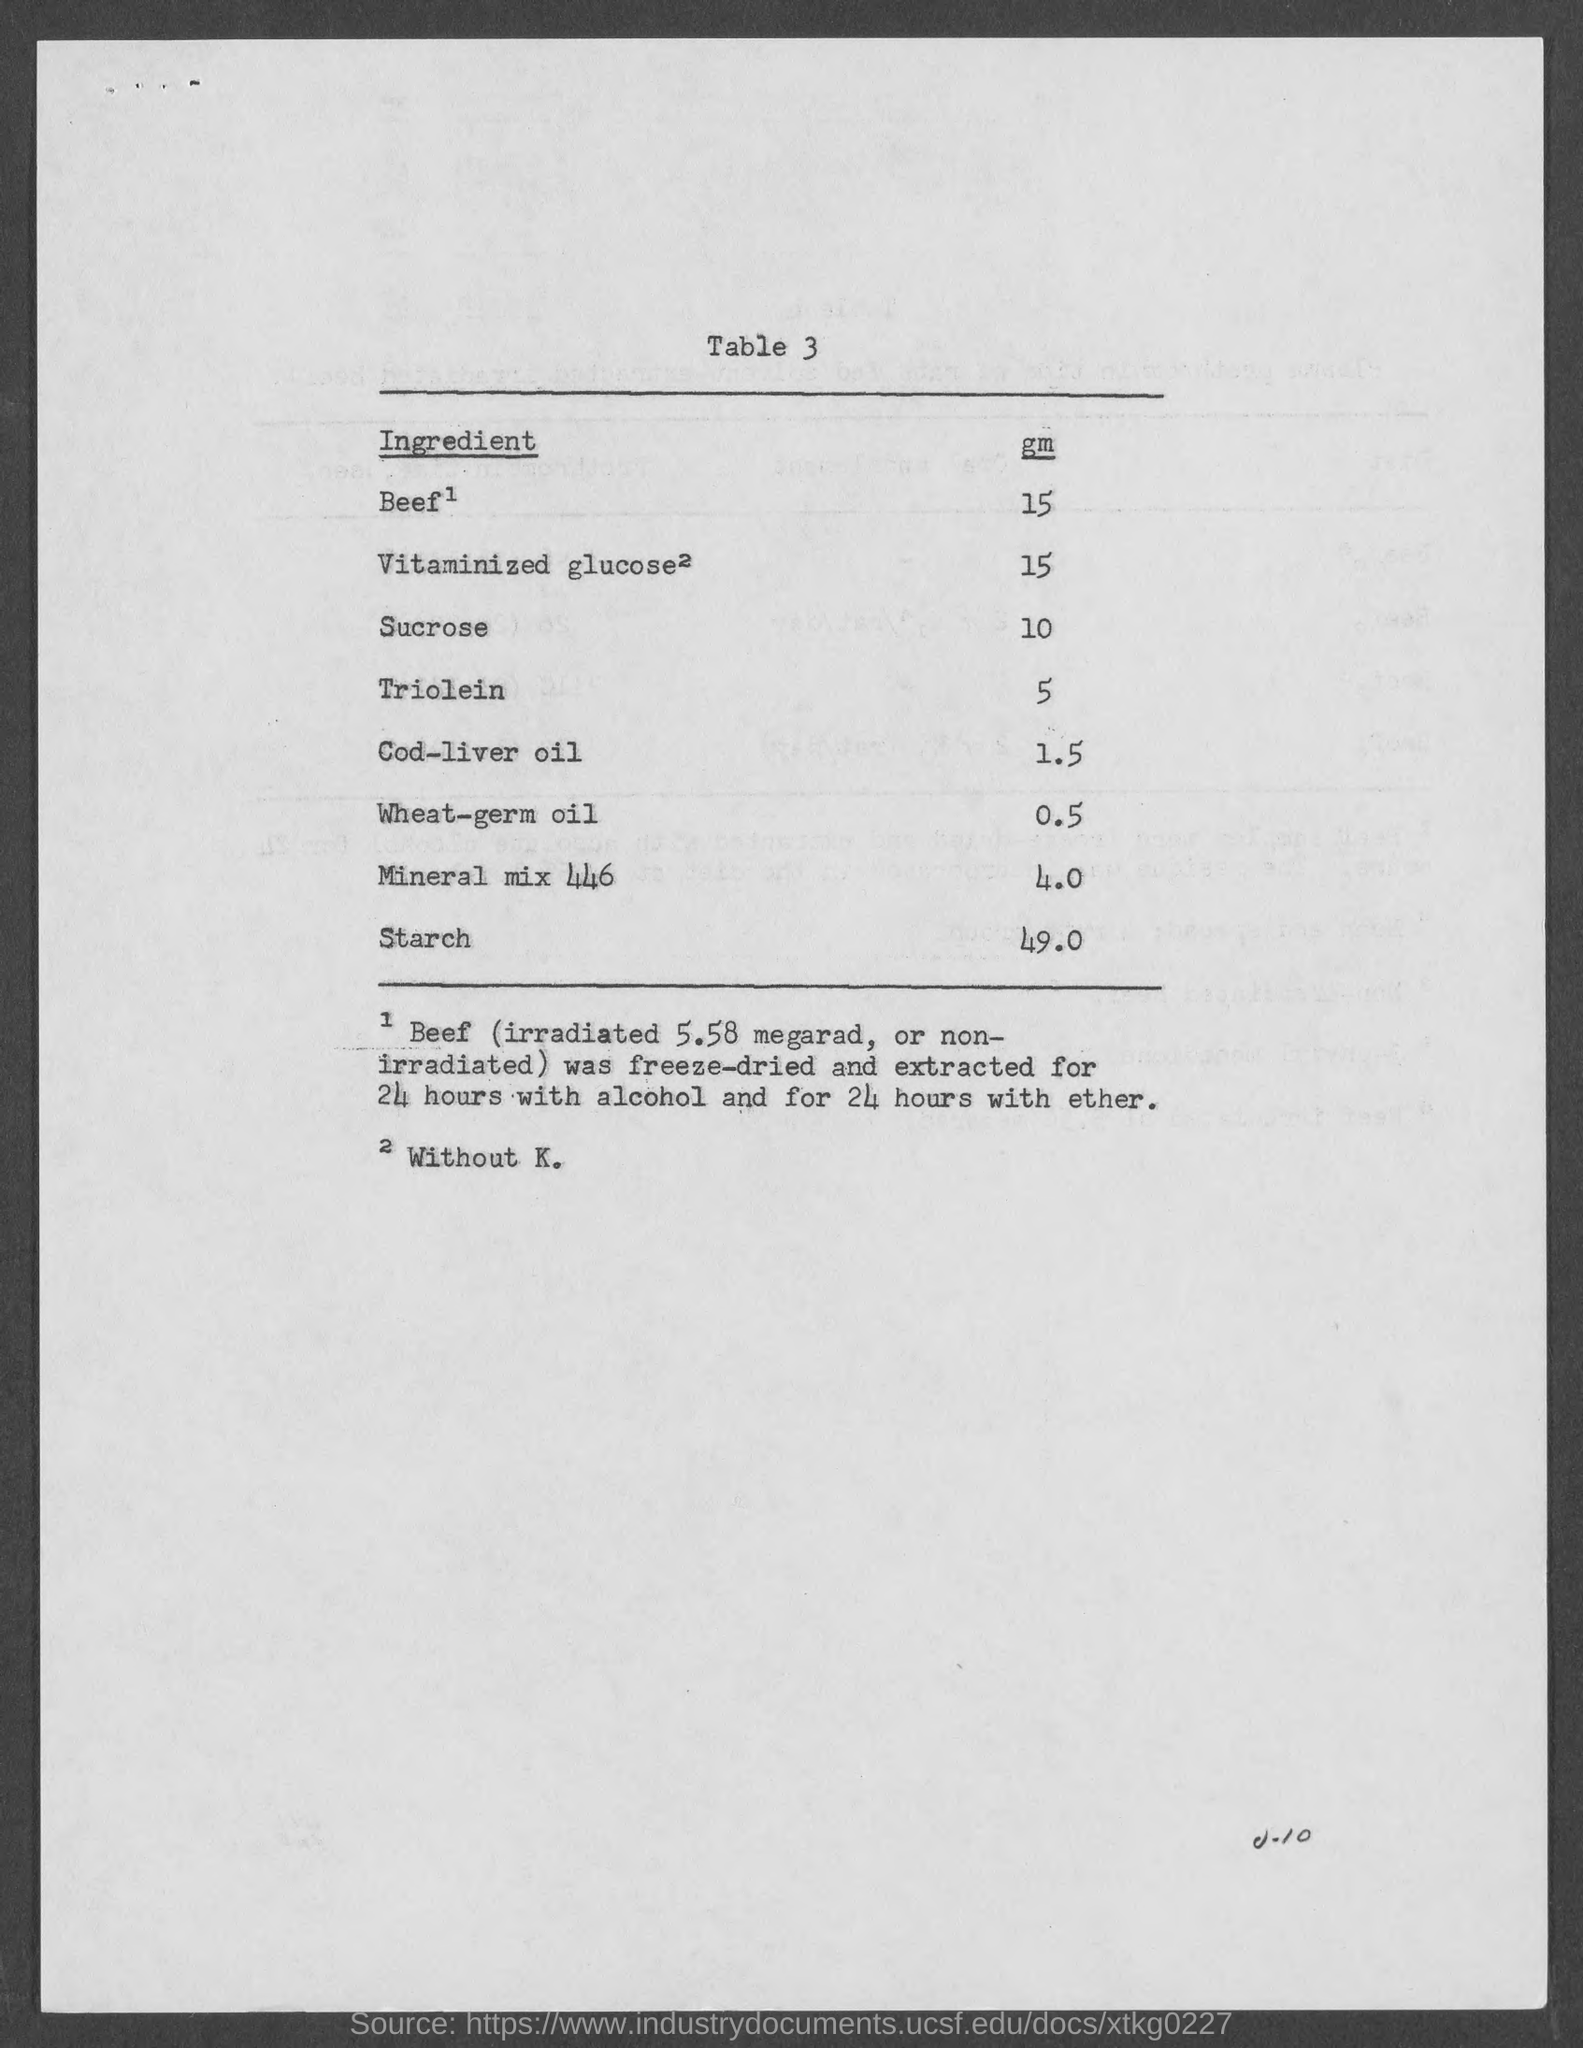Mention a couple of crucial points in this snapshot. Starch is present in a significant amount. The amount of cod-liver oil is 1.5. The ingredient that is present in a small amount is wheat-germ oil. The amount of starch is 49.0... 